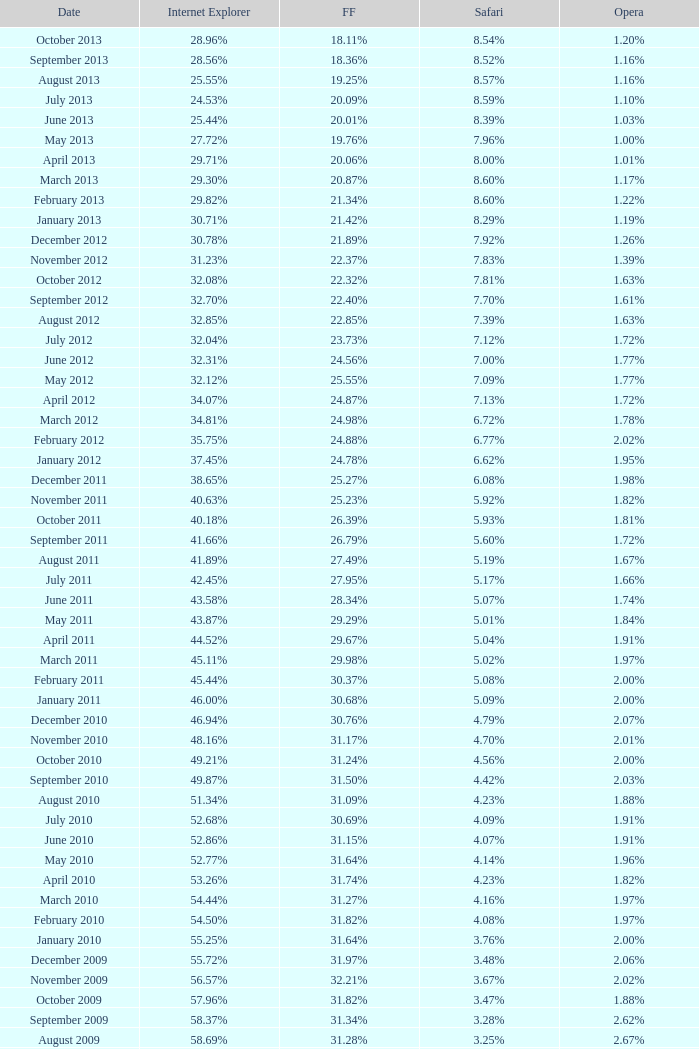What percentage of browsers were using Internet Explorer during the period in which 27.85% were using Firefox? 64.43%. 